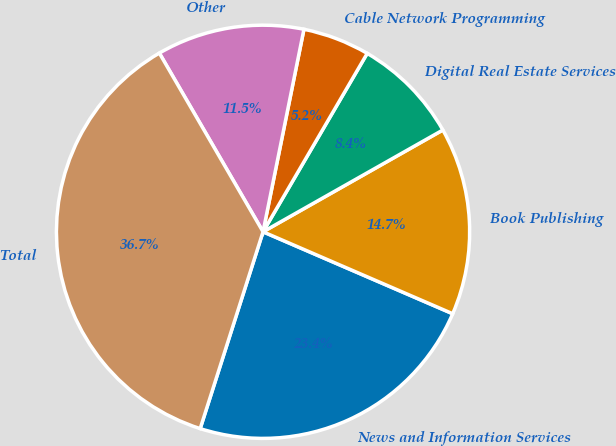Convert chart to OTSL. <chart><loc_0><loc_0><loc_500><loc_500><pie_chart><fcel>News and Information Services<fcel>Book Publishing<fcel>Digital Real Estate Services<fcel>Cable Network Programming<fcel>Other<fcel>Total<nl><fcel>23.43%<fcel>14.69%<fcel>8.39%<fcel>5.24%<fcel>11.54%<fcel>36.71%<nl></chart> 